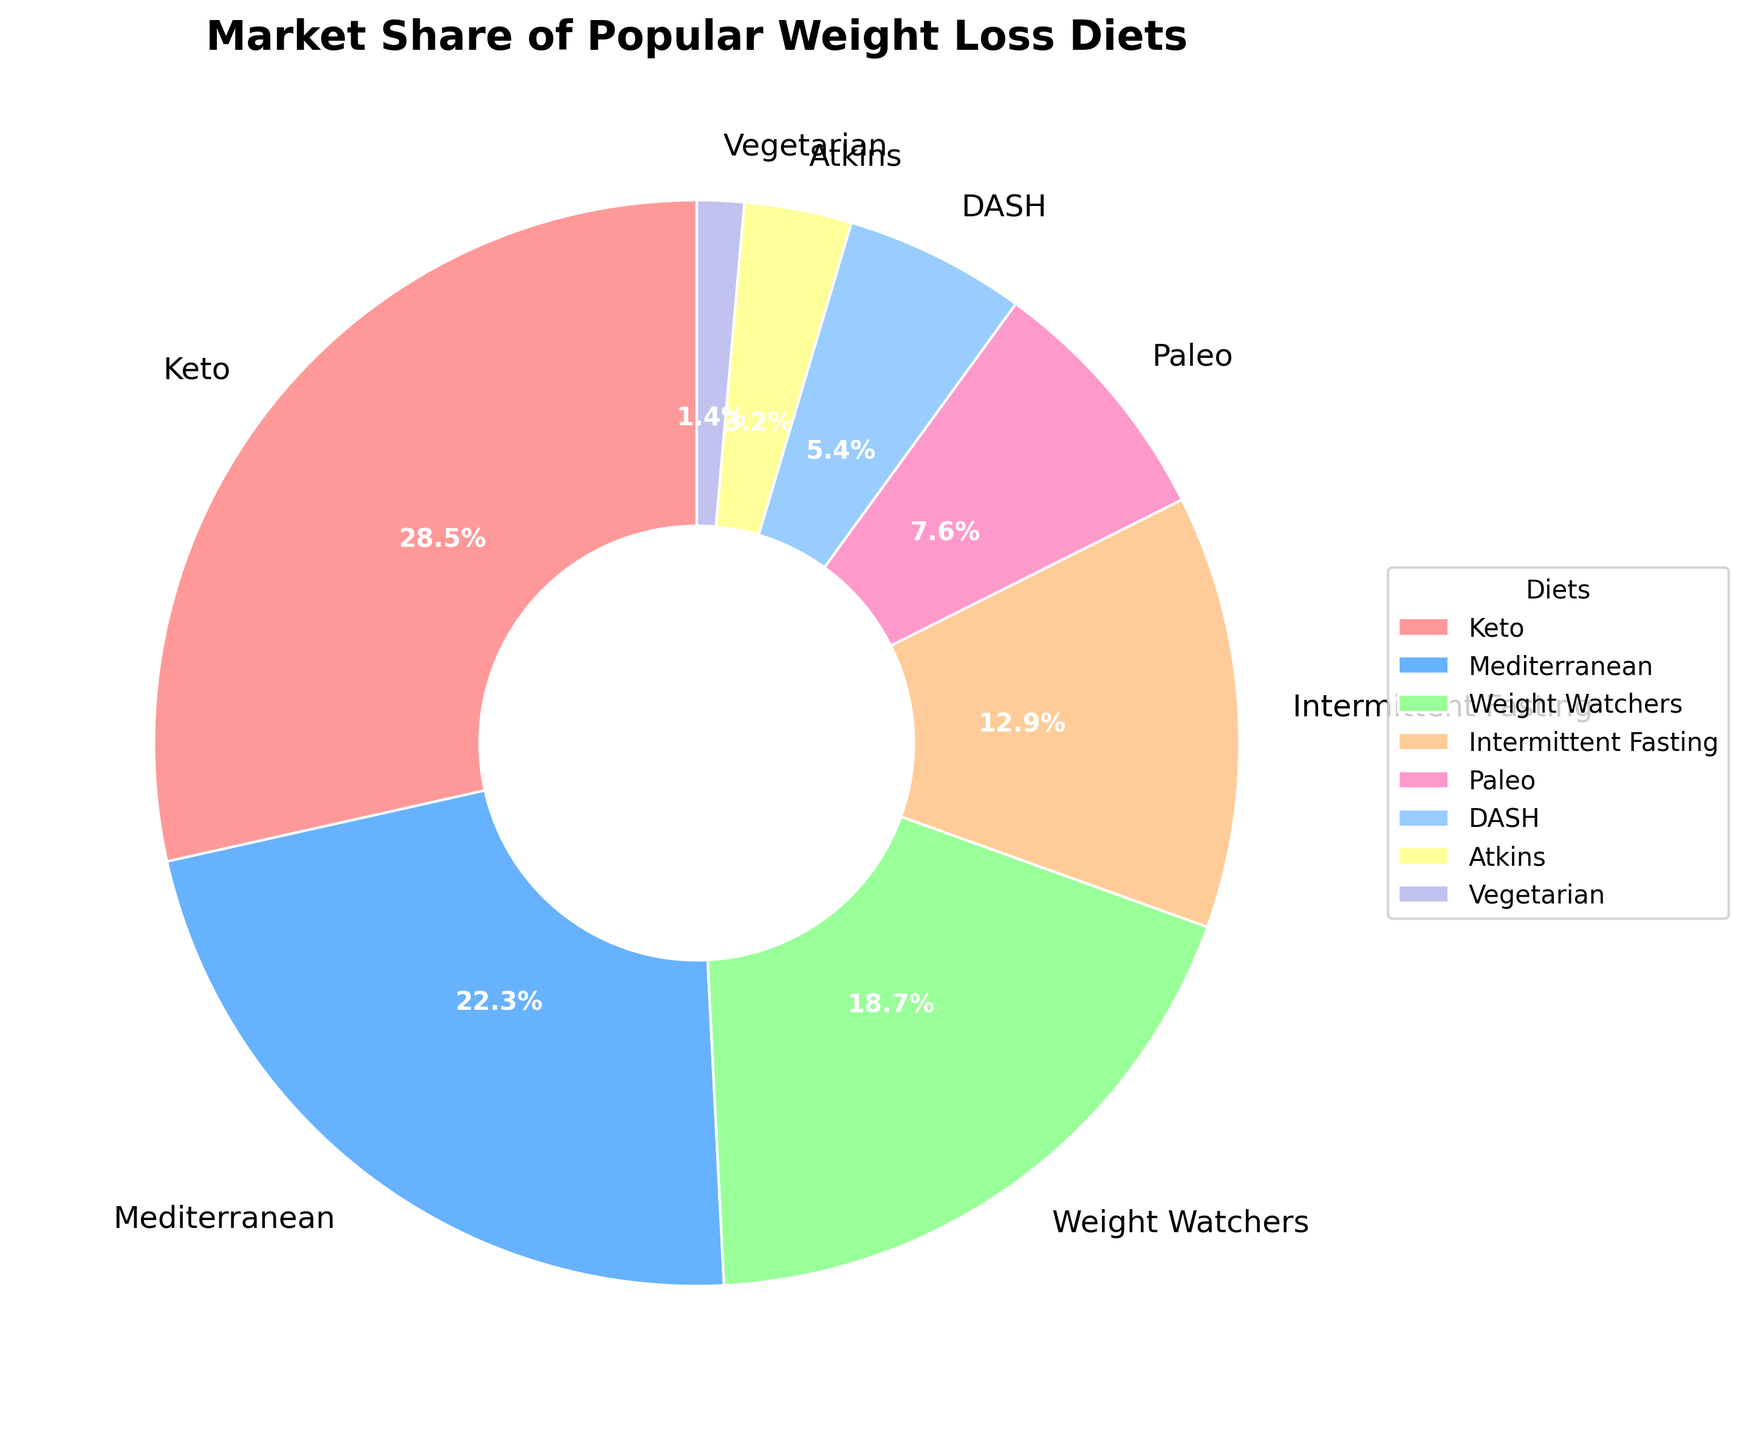Which diet has the largest market share? The largest segment in the pie chart corresponds to the Keto diet
Answer: Keto How much larger is the market share of the Keto diet compared to the Vegetarian diet? The Keto diet has a market share of 28.5%, and the Vegetarian diet has a market share of 1.4%. The difference is 28.5% - 1.4%
Answer: 27.1% Which colors represent the Mediterranean diet and the DASH diet? The Mediterranean diet is represented by the blue segment, and the DASH diet by the light pink segment.
Answer: Blue and Pink What is the combined market share of the Paleo and Atkins diets? The market share of the Paleo diet is 7.6% and the Atkins diet is 3.2%. The total is 7.6% + 3.2%
Answer: 10.8% Which diet has a smaller market share: Weight Watchers or Intermittent Fasting? According to the pie chart, Intermittent Fasting has a smaller market share (12.9%) compared to Weight Watchers (18.7%)
Answer: Intermittent Fasting What is the difference in market share between the two smallest segments? The two smallest market share segments are Atkins (3.2%) and Vegetarian (1.4%). The difference is 3.2% - 1.4%.
Answer: 1.8% What percentage of the market is captured by diets other than Keto and Mediterranean? First, sum the market shares of Keto and Mediterranean: 28.5% + 22.3% = 50.8%. Subtract this from 100% to find the rest of the market: 100% - 50.8%
Answer: 49.2% What is the market share of the diet represented by the orange segment? The orange segment corresponds to Intermittent Fasting, which has a market share of 12.9%
Answer: 12.9% What are the three diets with the highest market shares? The pie chart shows that the three diets with the highest market shares are Keto (28.5%), Mediterranean (22.3%), and Weight Watchers (18.7%)
Answer: Keto, Mediterranean, and Weight Watchers 